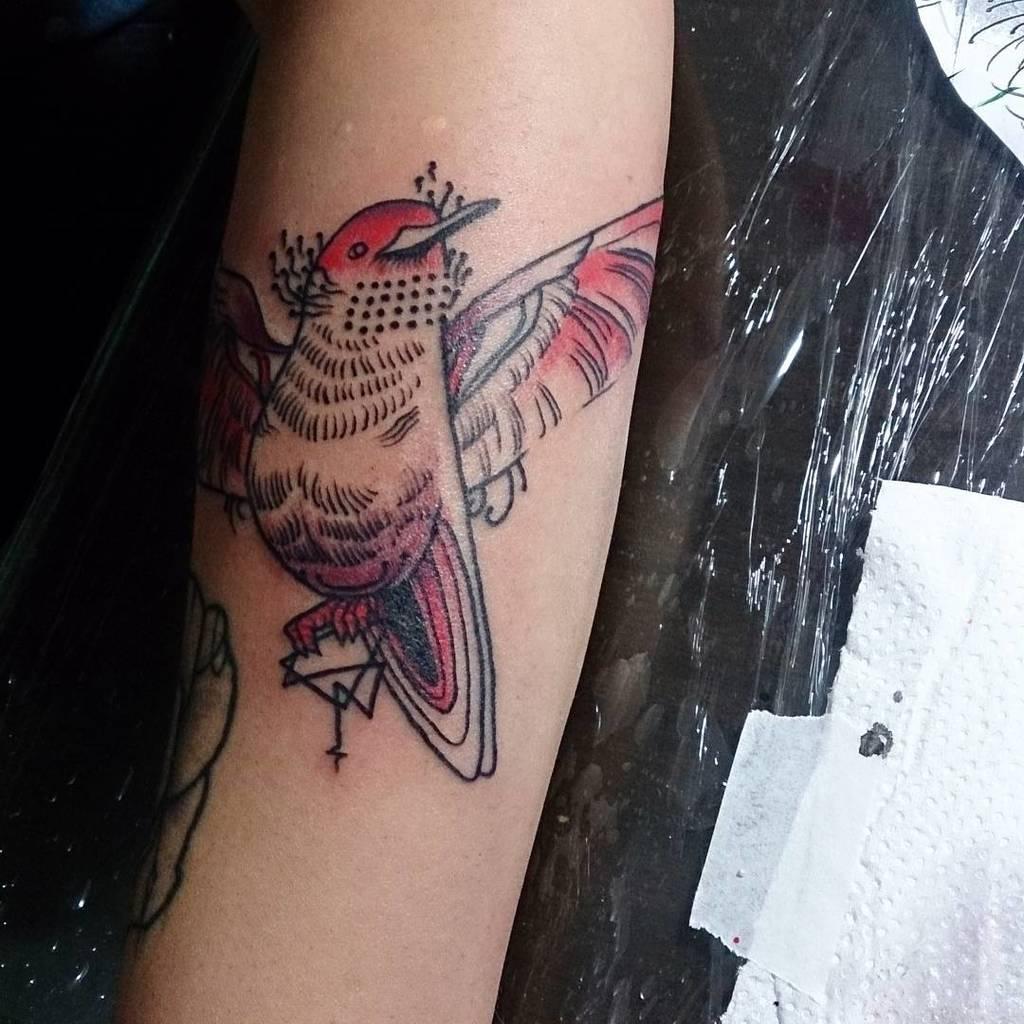Please provide a concise description of this image. In this image I can see a person hand on which I can see a tattoo, and under the person hand I can see a black color cover. 